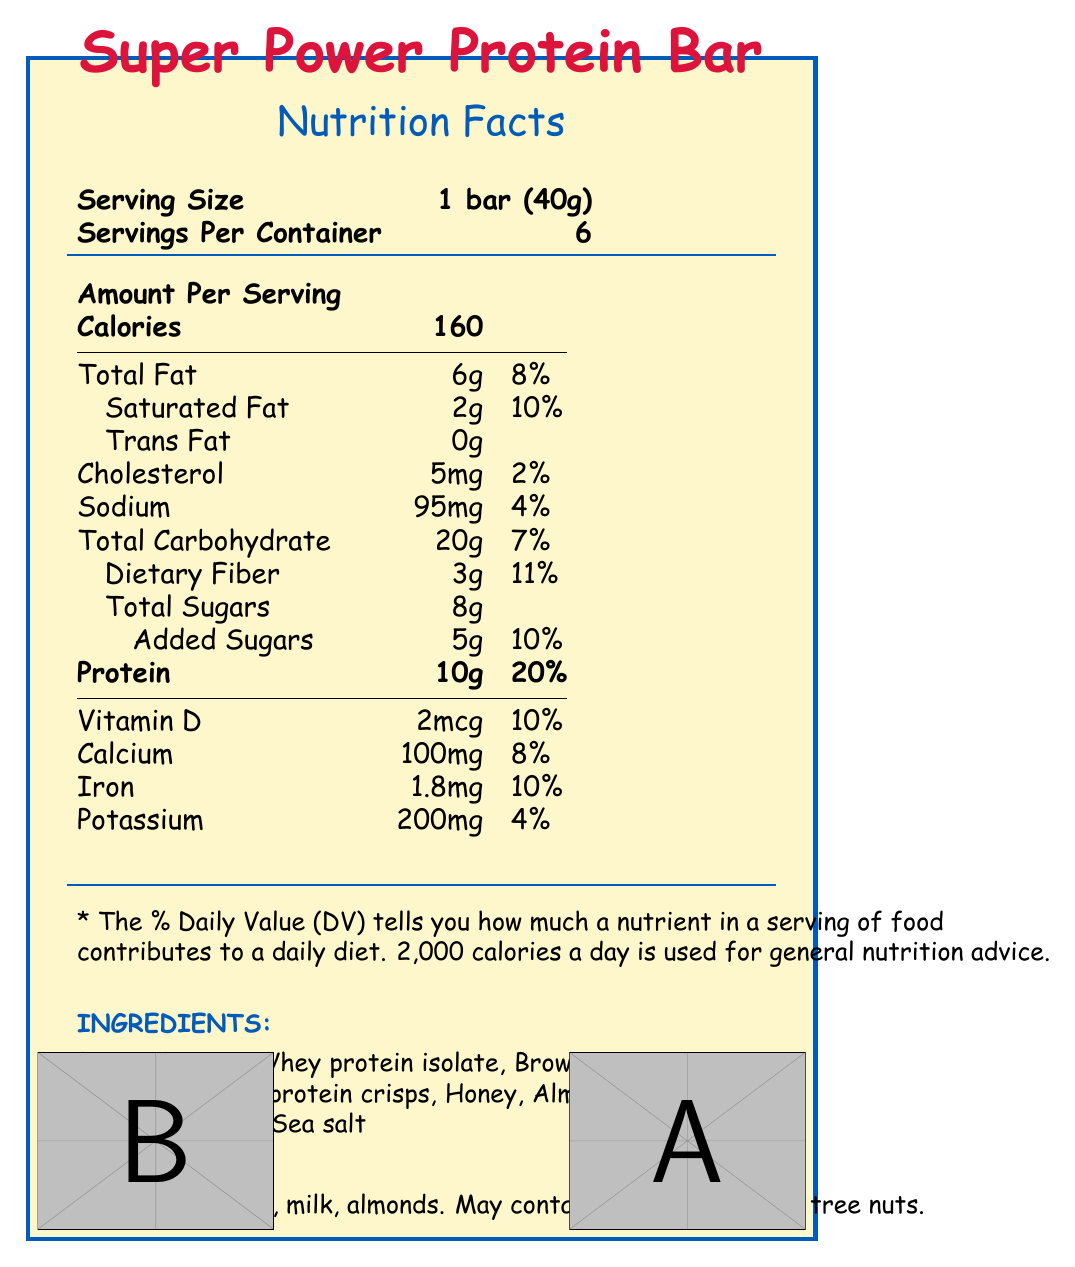what is the serving size of the Super Power Protein Bar? The serving size is stated clearly in the document in the "Serving Size" category.
Answer: 1 bar (40g) how many calories are in one serving? The document specifies the number of calories per serving under the "Amount Per Serving" section.
Answer: 160 What is the protein content per serving, and what percentage of the daily value does it represent? The document shows that each serving contains 10g of protein, representing 20% of the daily value.
Answer: 10g, 20% what are the allergens listed in the document? The allergens are listed at the bottom of the document under "Allergens."
Answer: Contains peanuts, milk, almonds. May contain traces of soy and tree nuts. What is the theme of the packaging for the Super Power Protein Bar? The document states that the packaging theme is "Superhero."
Answer: Superhero which of the following is NOT an ingredient in the Super Power Protein Bar? A. Honey B. Peanut butter C. Artificial colors D. Almonds The list of ingredients does not include artificial colors according to the "Ingredients" section of the document.
Answer: C. Artificial colors What is the daily value percentage of saturated fat per serving? A. 5% B. 10% C. 15% The document specifies that the daily value percentage of saturated fat per serving is 10%.
Answer: B. 10% Which macronutrient has the highest daily value percentage per serving in the Super Power Protein Bar? A. Total Fat B. Total Carbohydrate C. Protein D. Cholesterol From the "Amount Per Serving" section, protein has the highest daily value percentage at 20%.
Answer: C. Protein can the Super Power Protein Bar be stored in a warm place? The storage instructions specify that the bar should be stored in a cool, dry place.
Answer: No summarize the main idea of the document. The document comprehensively details the nutrition facts, ingredients, packaging, and storage for the Super Power Protein Bar, emphasizing its appeal to kids with superhero-themed designs and substantial protein content.
Answer: The document provides detailed nutrition and ingredient information for the Super Power Protein Bar, a superhero-themed, protein-packed snack designed for active kids aged 6-12, including nutritional values, ingredients, allergens, packaging features, and storage instructions. what is the website for Super Snacks Inc.? The website is listed in the manufacturer's contact information section at the end of the document.
Answer: www.supersnaclks.com how many bars are in one container? The document states that there are 6 servings per container, with each serving being one bar.
Answer: 6 how is the document designed? A. Simple text layout B. Graphical and colorful C. Minimalist design D. Only text-based The document features comic book-style illustrations, bold typography, and energy burst graphics, making it graphical and colorful.
Answer: B. Graphical and colorful What type of flavors does the Super Power Protein Bar contain? According to the "Ingredients" section, the bar contains natural flavors.
Answer: Natural flavors Is this product suitable for someone with a tree nut allergy? The allergens section states that the product contains almonds and may also contain traces of tree nuts.
Answer: No 